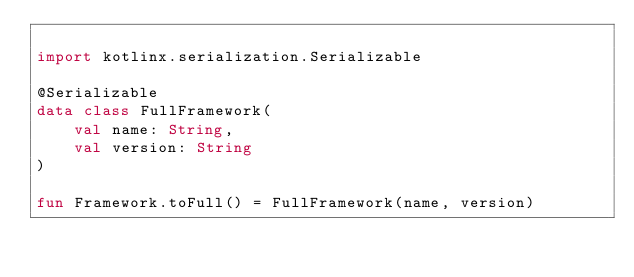<code> <loc_0><loc_0><loc_500><loc_500><_Kotlin_>
import kotlinx.serialization.Serializable

@Serializable
data class FullFramework(
    val name: String,
    val version: String
)

fun Framework.toFull() = FullFramework(name, version)</code> 